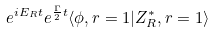Convert formula to latex. <formula><loc_0><loc_0><loc_500><loc_500>e ^ { i E _ { R } t } e ^ { \frac { \Gamma } { 2 } t } \langle \phi , r = 1 | Z _ { R } ^ { \ast } , r = 1 \rangle</formula> 